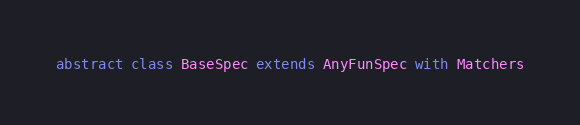Convert code to text. <code><loc_0><loc_0><loc_500><loc_500><_Scala_>
abstract class BaseSpec extends AnyFunSpec with Matchers
</code> 